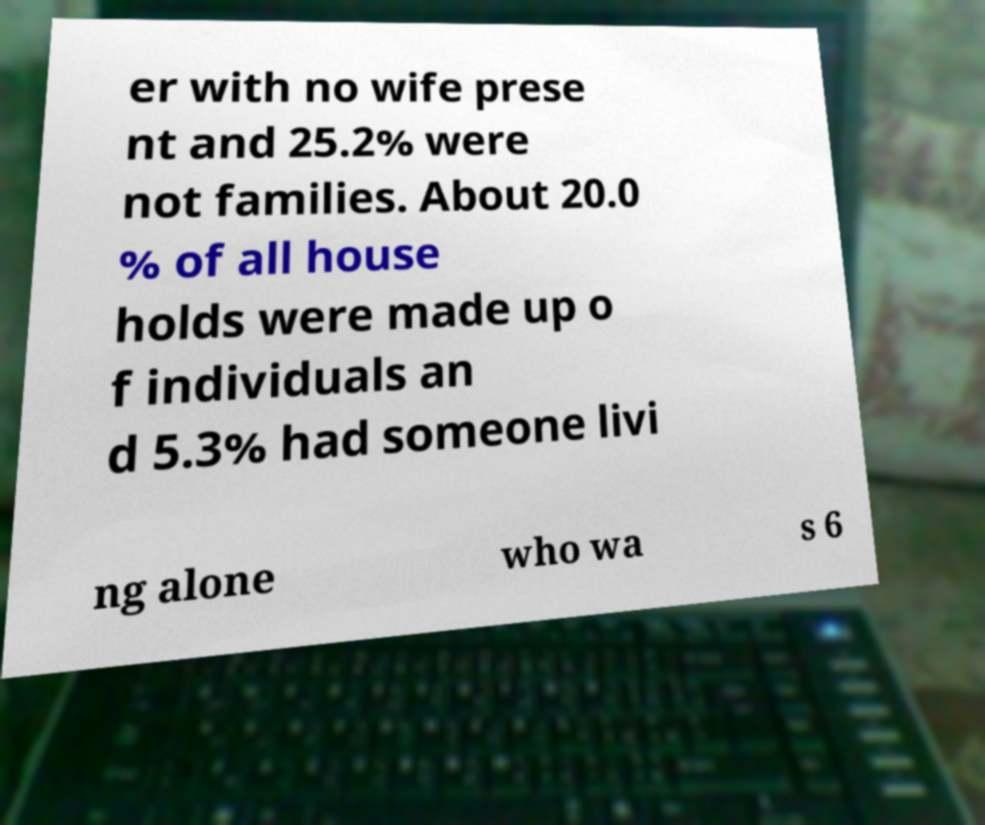I need the written content from this picture converted into text. Can you do that? er with no wife prese nt and 25.2% were not families. About 20.0 % of all house holds were made up o f individuals an d 5.3% had someone livi ng alone who wa s 6 